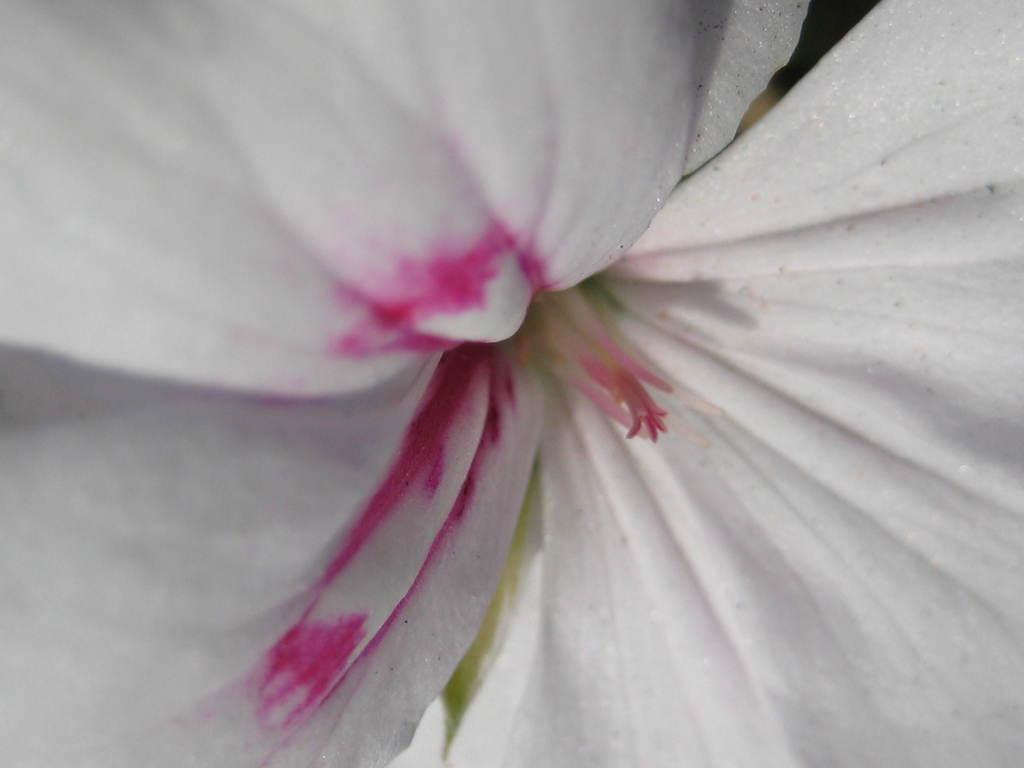What is the main subject of the picture? The main subject of the picture is a flower. Can you describe the color of the flower? The flower is white in color. What type of skirt is visible in the picture? There is no skirt present in the picture; it features a white flower. How much credit is available on the flower in the picture? There is no credit associated with the flower in the picture; it is a natural object. 